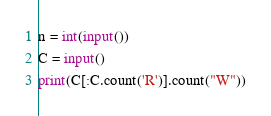Convert code to text. <code><loc_0><loc_0><loc_500><loc_500><_Python_>n = int(input())
C = input()
print(C[:C.count('R')].count("W"))</code> 